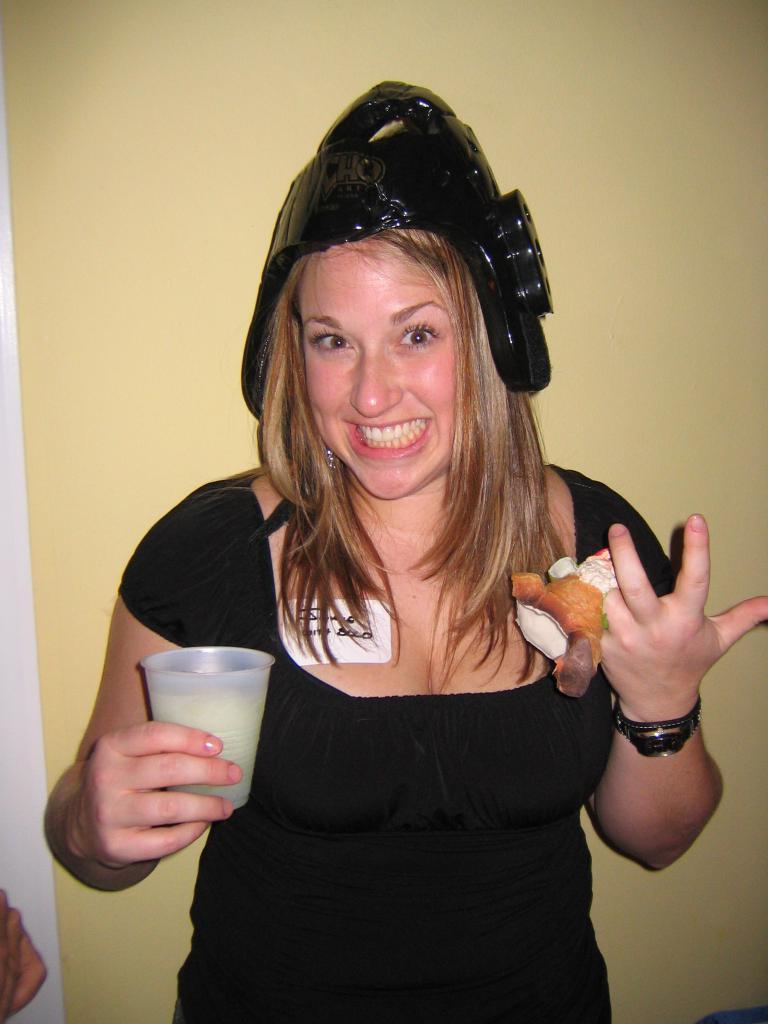Can you describe this image briefly? This is the woman standing and smiling. She wore a kind of a helmet. She is holding a glass and food in her hands. In the background, that looks like a wall, which is light yellow in color. 